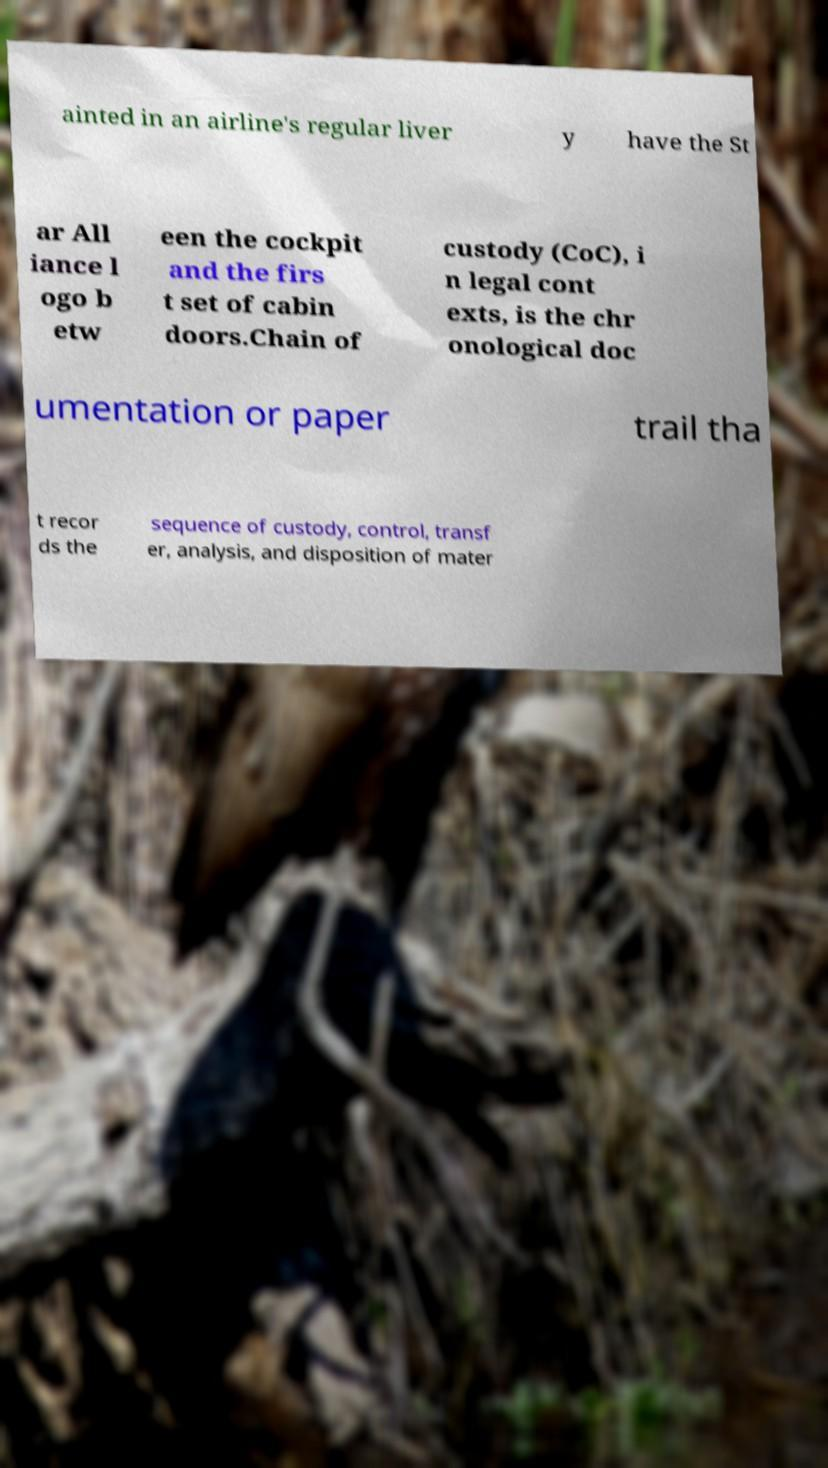Please identify and transcribe the text found in this image. ainted in an airline's regular liver y have the St ar All iance l ogo b etw een the cockpit and the firs t set of cabin doors.Chain of custody (CoC), i n legal cont exts, is the chr onological doc umentation or paper trail tha t recor ds the sequence of custody, control, transf er, analysis, and disposition of mater 